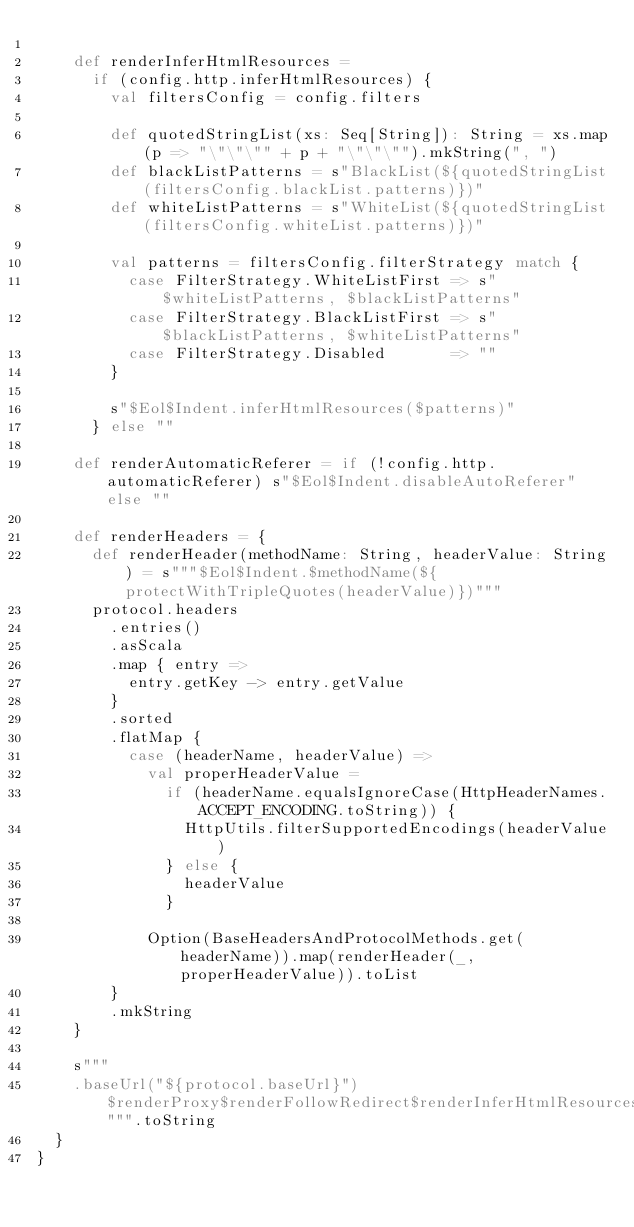Convert code to text. <code><loc_0><loc_0><loc_500><loc_500><_Scala_>
    def renderInferHtmlResources =
      if (config.http.inferHtmlResources) {
        val filtersConfig = config.filters

        def quotedStringList(xs: Seq[String]): String = xs.map(p => "\"\"\"" + p + "\"\"\"").mkString(", ")
        def blackListPatterns = s"BlackList(${quotedStringList(filtersConfig.blackList.patterns)})"
        def whiteListPatterns = s"WhiteList(${quotedStringList(filtersConfig.whiteList.patterns)})"

        val patterns = filtersConfig.filterStrategy match {
          case FilterStrategy.WhiteListFirst => s"$whiteListPatterns, $blackListPatterns"
          case FilterStrategy.BlackListFirst => s"$blackListPatterns, $whiteListPatterns"
          case FilterStrategy.Disabled       => ""
        }

        s"$Eol$Indent.inferHtmlResources($patterns)"
      } else ""

    def renderAutomaticReferer = if (!config.http.automaticReferer) s"$Eol$Indent.disableAutoReferer" else ""

    def renderHeaders = {
      def renderHeader(methodName: String, headerValue: String) = s"""$Eol$Indent.$methodName(${protectWithTripleQuotes(headerValue)})"""
      protocol.headers
        .entries()
        .asScala
        .map { entry =>
          entry.getKey -> entry.getValue
        }
        .sorted
        .flatMap {
          case (headerName, headerValue) =>
            val properHeaderValue =
              if (headerName.equalsIgnoreCase(HttpHeaderNames.ACCEPT_ENCODING.toString)) {
                HttpUtils.filterSupportedEncodings(headerValue)
              } else {
                headerValue
              }

            Option(BaseHeadersAndProtocolMethods.get(headerName)).map(renderHeader(_, properHeaderValue)).toList
        }
        .mkString
    }

    s"""
		.baseUrl("${protocol.baseUrl}")$renderProxy$renderFollowRedirect$renderInferHtmlResources$renderAutomaticReferer$renderHeaders""".toString
  }
}
</code> 